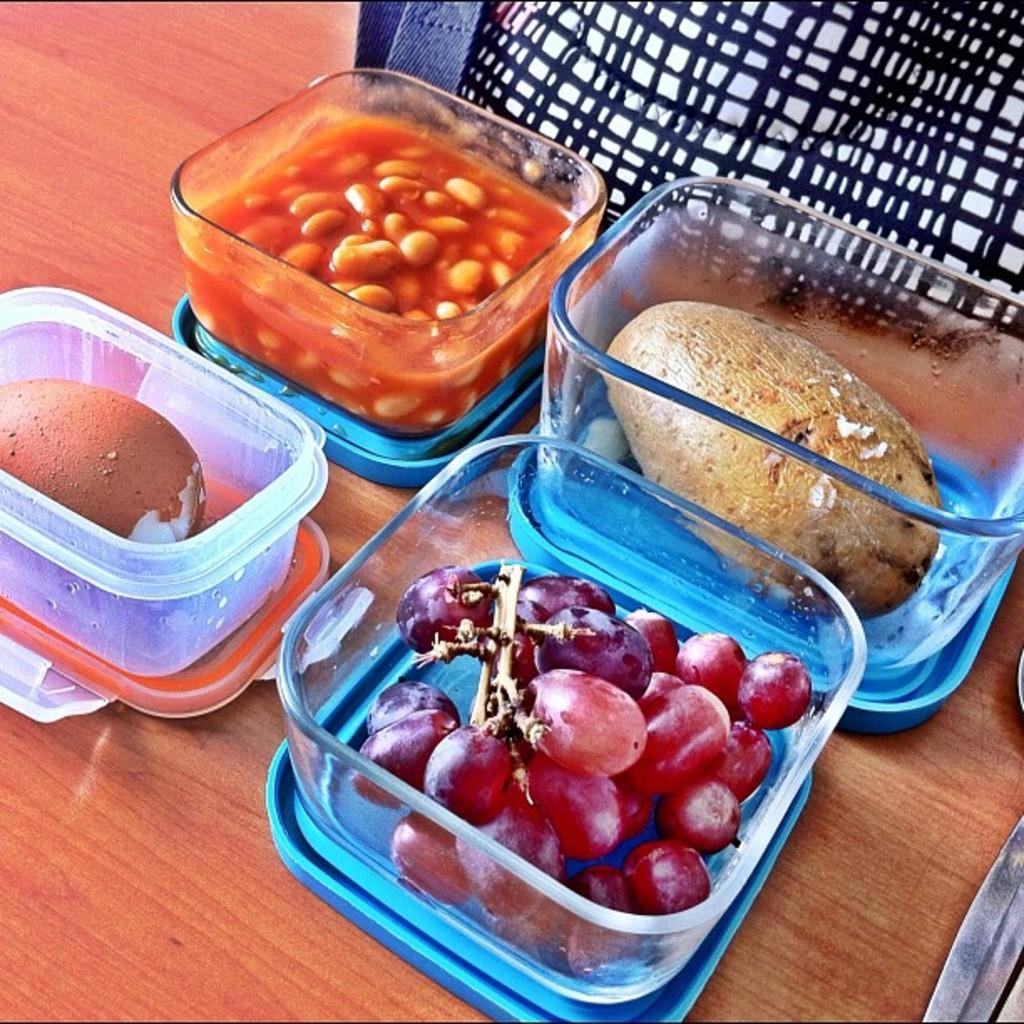What is the main object on which other items are placed? There is a table in the image. How many boxes are on the table? There are 4 boxes on the table. What do the boxes contain? The boxes contain eatables. Can you name two specific eatables that are visible in the image? Yes, there is an egg and grapes among the eatables. Is there a guide available to help with the expansion of the boxes in the image? There is no mention of a guide or expansion of the boxes in the image; the focus is on the table, boxes, and their contents. 